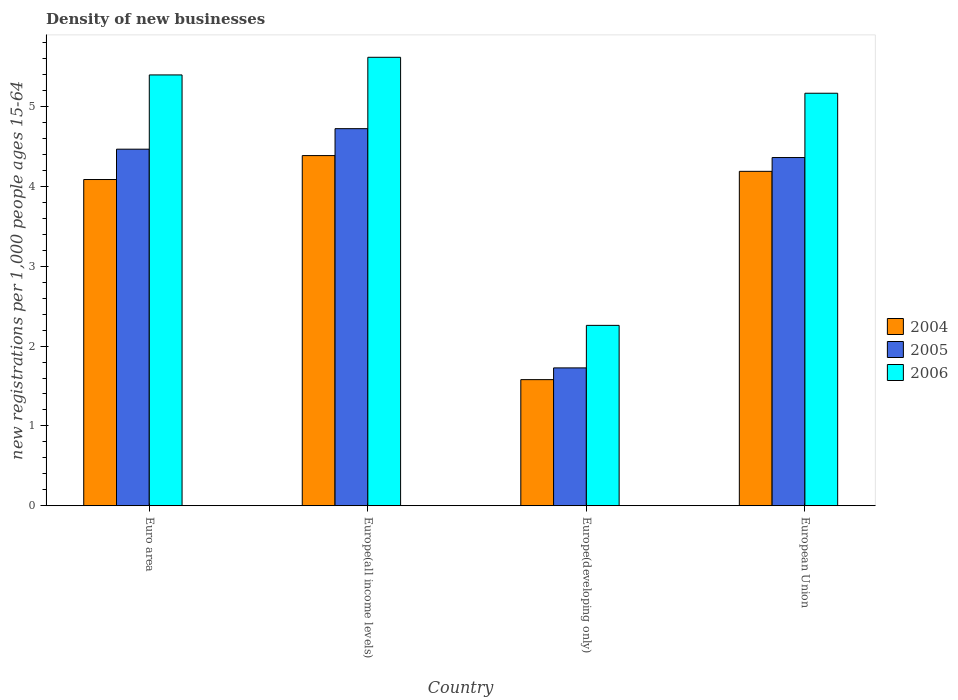How many groups of bars are there?
Your answer should be compact. 4. Are the number of bars per tick equal to the number of legend labels?
Give a very brief answer. Yes. Are the number of bars on each tick of the X-axis equal?
Offer a very short reply. Yes. How many bars are there on the 3rd tick from the right?
Offer a terse response. 3. What is the label of the 3rd group of bars from the left?
Provide a succinct answer. Europe(developing only). What is the number of new registrations in 2006 in European Union?
Provide a succinct answer. 5.17. Across all countries, what is the maximum number of new registrations in 2004?
Offer a terse response. 4.39. Across all countries, what is the minimum number of new registrations in 2004?
Your answer should be very brief. 1.58. In which country was the number of new registrations in 2004 maximum?
Your answer should be compact. Europe(all income levels). In which country was the number of new registrations in 2005 minimum?
Your response must be concise. Europe(developing only). What is the total number of new registrations in 2004 in the graph?
Provide a short and direct response. 14.24. What is the difference between the number of new registrations in 2006 in Europe(all income levels) and that in European Union?
Offer a terse response. 0.45. What is the difference between the number of new registrations in 2004 in Europe(all income levels) and the number of new registrations in 2005 in European Union?
Your response must be concise. 0.02. What is the average number of new registrations in 2006 per country?
Keep it short and to the point. 4.61. What is the difference between the number of new registrations of/in 2005 and number of new registrations of/in 2004 in Europe(all income levels)?
Your answer should be very brief. 0.34. In how many countries, is the number of new registrations in 2004 greater than 1.8?
Make the answer very short. 3. What is the ratio of the number of new registrations in 2004 in Euro area to that in Europe(all income levels)?
Your answer should be very brief. 0.93. What is the difference between the highest and the second highest number of new registrations in 2004?
Your answer should be very brief. 0.2. What is the difference between the highest and the lowest number of new registrations in 2004?
Keep it short and to the point. 2.81. In how many countries, is the number of new registrations in 2006 greater than the average number of new registrations in 2006 taken over all countries?
Give a very brief answer. 3. Is the sum of the number of new registrations in 2006 in Euro area and European Union greater than the maximum number of new registrations in 2004 across all countries?
Keep it short and to the point. Yes. What does the 3rd bar from the left in Europe(all income levels) represents?
Your response must be concise. 2006. What does the 2nd bar from the right in Europe(developing only) represents?
Provide a short and direct response. 2005. Is it the case that in every country, the sum of the number of new registrations in 2006 and number of new registrations in 2005 is greater than the number of new registrations in 2004?
Offer a very short reply. Yes. How many bars are there?
Provide a short and direct response. 12. Are all the bars in the graph horizontal?
Provide a short and direct response. No. What is the difference between two consecutive major ticks on the Y-axis?
Give a very brief answer. 1. Does the graph contain any zero values?
Make the answer very short. No. How many legend labels are there?
Keep it short and to the point. 3. What is the title of the graph?
Keep it short and to the point. Density of new businesses. Does "1999" appear as one of the legend labels in the graph?
Your answer should be compact. No. What is the label or title of the Y-axis?
Your response must be concise. New registrations per 1,0 people ages 15-64. What is the new registrations per 1,000 people ages 15-64 in 2004 in Euro area?
Your answer should be very brief. 4.09. What is the new registrations per 1,000 people ages 15-64 of 2005 in Euro area?
Your answer should be very brief. 4.47. What is the new registrations per 1,000 people ages 15-64 in 2006 in Euro area?
Make the answer very short. 5.4. What is the new registrations per 1,000 people ages 15-64 in 2004 in Europe(all income levels)?
Your answer should be compact. 4.39. What is the new registrations per 1,000 people ages 15-64 of 2005 in Europe(all income levels)?
Offer a terse response. 4.72. What is the new registrations per 1,000 people ages 15-64 of 2006 in Europe(all income levels)?
Your response must be concise. 5.62. What is the new registrations per 1,000 people ages 15-64 of 2004 in Europe(developing only)?
Ensure brevity in your answer.  1.58. What is the new registrations per 1,000 people ages 15-64 of 2005 in Europe(developing only)?
Offer a terse response. 1.73. What is the new registrations per 1,000 people ages 15-64 of 2006 in Europe(developing only)?
Provide a short and direct response. 2.26. What is the new registrations per 1,000 people ages 15-64 of 2004 in European Union?
Ensure brevity in your answer.  4.19. What is the new registrations per 1,000 people ages 15-64 in 2005 in European Union?
Offer a terse response. 4.36. What is the new registrations per 1,000 people ages 15-64 of 2006 in European Union?
Your response must be concise. 5.17. Across all countries, what is the maximum new registrations per 1,000 people ages 15-64 in 2004?
Give a very brief answer. 4.39. Across all countries, what is the maximum new registrations per 1,000 people ages 15-64 in 2005?
Ensure brevity in your answer.  4.72. Across all countries, what is the maximum new registrations per 1,000 people ages 15-64 of 2006?
Your response must be concise. 5.62. Across all countries, what is the minimum new registrations per 1,000 people ages 15-64 of 2004?
Offer a very short reply. 1.58. Across all countries, what is the minimum new registrations per 1,000 people ages 15-64 of 2005?
Provide a succinct answer. 1.73. Across all countries, what is the minimum new registrations per 1,000 people ages 15-64 in 2006?
Offer a very short reply. 2.26. What is the total new registrations per 1,000 people ages 15-64 of 2004 in the graph?
Offer a very short reply. 14.24. What is the total new registrations per 1,000 people ages 15-64 in 2005 in the graph?
Provide a short and direct response. 15.28. What is the total new registrations per 1,000 people ages 15-64 in 2006 in the graph?
Give a very brief answer. 18.44. What is the difference between the new registrations per 1,000 people ages 15-64 of 2004 in Euro area and that in Europe(all income levels)?
Ensure brevity in your answer.  -0.3. What is the difference between the new registrations per 1,000 people ages 15-64 in 2005 in Euro area and that in Europe(all income levels)?
Your response must be concise. -0.26. What is the difference between the new registrations per 1,000 people ages 15-64 of 2006 in Euro area and that in Europe(all income levels)?
Your answer should be compact. -0.22. What is the difference between the new registrations per 1,000 people ages 15-64 of 2004 in Euro area and that in Europe(developing only)?
Ensure brevity in your answer.  2.51. What is the difference between the new registrations per 1,000 people ages 15-64 in 2005 in Euro area and that in Europe(developing only)?
Keep it short and to the point. 2.74. What is the difference between the new registrations per 1,000 people ages 15-64 of 2006 in Euro area and that in Europe(developing only)?
Your response must be concise. 3.14. What is the difference between the new registrations per 1,000 people ages 15-64 of 2004 in Euro area and that in European Union?
Offer a terse response. -0.1. What is the difference between the new registrations per 1,000 people ages 15-64 in 2005 in Euro area and that in European Union?
Your response must be concise. 0.1. What is the difference between the new registrations per 1,000 people ages 15-64 in 2006 in Euro area and that in European Union?
Ensure brevity in your answer.  0.23. What is the difference between the new registrations per 1,000 people ages 15-64 of 2004 in Europe(all income levels) and that in Europe(developing only)?
Your answer should be very brief. 2.81. What is the difference between the new registrations per 1,000 people ages 15-64 in 2005 in Europe(all income levels) and that in Europe(developing only)?
Offer a very short reply. 3. What is the difference between the new registrations per 1,000 people ages 15-64 in 2006 in Europe(all income levels) and that in Europe(developing only)?
Offer a terse response. 3.36. What is the difference between the new registrations per 1,000 people ages 15-64 in 2004 in Europe(all income levels) and that in European Union?
Offer a terse response. 0.2. What is the difference between the new registrations per 1,000 people ages 15-64 in 2005 in Europe(all income levels) and that in European Union?
Give a very brief answer. 0.36. What is the difference between the new registrations per 1,000 people ages 15-64 in 2006 in Europe(all income levels) and that in European Union?
Provide a short and direct response. 0.45. What is the difference between the new registrations per 1,000 people ages 15-64 of 2004 in Europe(developing only) and that in European Union?
Your response must be concise. -2.61. What is the difference between the new registrations per 1,000 people ages 15-64 in 2005 in Europe(developing only) and that in European Union?
Provide a short and direct response. -2.64. What is the difference between the new registrations per 1,000 people ages 15-64 of 2006 in Europe(developing only) and that in European Union?
Give a very brief answer. -2.91. What is the difference between the new registrations per 1,000 people ages 15-64 of 2004 in Euro area and the new registrations per 1,000 people ages 15-64 of 2005 in Europe(all income levels)?
Give a very brief answer. -0.64. What is the difference between the new registrations per 1,000 people ages 15-64 in 2004 in Euro area and the new registrations per 1,000 people ages 15-64 in 2006 in Europe(all income levels)?
Offer a terse response. -1.53. What is the difference between the new registrations per 1,000 people ages 15-64 of 2005 in Euro area and the new registrations per 1,000 people ages 15-64 of 2006 in Europe(all income levels)?
Your response must be concise. -1.15. What is the difference between the new registrations per 1,000 people ages 15-64 in 2004 in Euro area and the new registrations per 1,000 people ages 15-64 in 2005 in Europe(developing only)?
Your answer should be very brief. 2.36. What is the difference between the new registrations per 1,000 people ages 15-64 of 2004 in Euro area and the new registrations per 1,000 people ages 15-64 of 2006 in Europe(developing only)?
Provide a short and direct response. 1.83. What is the difference between the new registrations per 1,000 people ages 15-64 in 2005 in Euro area and the new registrations per 1,000 people ages 15-64 in 2006 in Europe(developing only)?
Keep it short and to the point. 2.21. What is the difference between the new registrations per 1,000 people ages 15-64 in 2004 in Euro area and the new registrations per 1,000 people ages 15-64 in 2005 in European Union?
Keep it short and to the point. -0.28. What is the difference between the new registrations per 1,000 people ages 15-64 in 2004 in Euro area and the new registrations per 1,000 people ages 15-64 in 2006 in European Union?
Your response must be concise. -1.08. What is the difference between the new registrations per 1,000 people ages 15-64 in 2005 in Euro area and the new registrations per 1,000 people ages 15-64 in 2006 in European Union?
Give a very brief answer. -0.7. What is the difference between the new registrations per 1,000 people ages 15-64 of 2004 in Europe(all income levels) and the new registrations per 1,000 people ages 15-64 of 2005 in Europe(developing only)?
Offer a very short reply. 2.66. What is the difference between the new registrations per 1,000 people ages 15-64 in 2004 in Europe(all income levels) and the new registrations per 1,000 people ages 15-64 in 2006 in Europe(developing only)?
Offer a terse response. 2.13. What is the difference between the new registrations per 1,000 people ages 15-64 in 2005 in Europe(all income levels) and the new registrations per 1,000 people ages 15-64 in 2006 in Europe(developing only)?
Give a very brief answer. 2.46. What is the difference between the new registrations per 1,000 people ages 15-64 of 2004 in Europe(all income levels) and the new registrations per 1,000 people ages 15-64 of 2005 in European Union?
Keep it short and to the point. 0.02. What is the difference between the new registrations per 1,000 people ages 15-64 of 2004 in Europe(all income levels) and the new registrations per 1,000 people ages 15-64 of 2006 in European Union?
Ensure brevity in your answer.  -0.78. What is the difference between the new registrations per 1,000 people ages 15-64 of 2005 in Europe(all income levels) and the new registrations per 1,000 people ages 15-64 of 2006 in European Union?
Keep it short and to the point. -0.44. What is the difference between the new registrations per 1,000 people ages 15-64 of 2004 in Europe(developing only) and the new registrations per 1,000 people ages 15-64 of 2005 in European Union?
Make the answer very short. -2.78. What is the difference between the new registrations per 1,000 people ages 15-64 of 2004 in Europe(developing only) and the new registrations per 1,000 people ages 15-64 of 2006 in European Union?
Give a very brief answer. -3.59. What is the difference between the new registrations per 1,000 people ages 15-64 in 2005 in Europe(developing only) and the new registrations per 1,000 people ages 15-64 in 2006 in European Union?
Your answer should be compact. -3.44. What is the average new registrations per 1,000 people ages 15-64 in 2004 per country?
Keep it short and to the point. 3.56. What is the average new registrations per 1,000 people ages 15-64 in 2005 per country?
Your response must be concise. 3.82. What is the average new registrations per 1,000 people ages 15-64 of 2006 per country?
Provide a succinct answer. 4.61. What is the difference between the new registrations per 1,000 people ages 15-64 of 2004 and new registrations per 1,000 people ages 15-64 of 2005 in Euro area?
Ensure brevity in your answer.  -0.38. What is the difference between the new registrations per 1,000 people ages 15-64 in 2004 and new registrations per 1,000 people ages 15-64 in 2006 in Euro area?
Offer a very short reply. -1.31. What is the difference between the new registrations per 1,000 people ages 15-64 of 2005 and new registrations per 1,000 people ages 15-64 of 2006 in Euro area?
Offer a very short reply. -0.93. What is the difference between the new registrations per 1,000 people ages 15-64 of 2004 and new registrations per 1,000 people ages 15-64 of 2005 in Europe(all income levels)?
Offer a very short reply. -0.34. What is the difference between the new registrations per 1,000 people ages 15-64 in 2004 and new registrations per 1,000 people ages 15-64 in 2006 in Europe(all income levels)?
Your response must be concise. -1.23. What is the difference between the new registrations per 1,000 people ages 15-64 of 2005 and new registrations per 1,000 people ages 15-64 of 2006 in Europe(all income levels)?
Give a very brief answer. -0.89. What is the difference between the new registrations per 1,000 people ages 15-64 in 2004 and new registrations per 1,000 people ages 15-64 in 2005 in Europe(developing only)?
Provide a succinct answer. -0.15. What is the difference between the new registrations per 1,000 people ages 15-64 in 2004 and new registrations per 1,000 people ages 15-64 in 2006 in Europe(developing only)?
Make the answer very short. -0.68. What is the difference between the new registrations per 1,000 people ages 15-64 in 2005 and new registrations per 1,000 people ages 15-64 in 2006 in Europe(developing only)?
Offer a very short reply. -0.53. What is the difference between the new registrations per 1,000 people ages 15-64 in 2004 and new registrations per 1,000 people ages 15-64 in 2005 in European Union?
Your response must be concise. -0.17. What is the difference between the new registrations per 1,000 people ages 15-64 of 2004 and new registrations per 1,000 people ages 15-64 of 2006 in European Union?
Make the answer very short. -0.98. What is the difference between the new registrations per 1,000 people ages 15-64 of 2005 and new registrations per 1,000 people ages 15-64 of 2006 in European Union?
Give a very brief answer. -0.81. What is the ratio of the new registrations per 1,000 people ages 15-64 in 2004 in Euro area to that in Europe(all income levels)?
Keep it short and to the point. 0.93. What is the ratio of the new registrations per 1,000 people ages 15-64 in 2005 in Euro area to that in Europe(all income levels)?
Offer a terse response. 0.95. What is the ratio of the new registrations per 1,000 people ages 15-64 in 2006 in Euro area to that in Europe(all income levels)?
Provide a succinct answer. 0.96. What is the ratio of the new registrations per 1,000 people ages 15-64 in 2004 in Euro area to that in Europe(developing only)?
Offer a very short reply. 2.59. What is the ratio of the new registrations per 1,000 people ages 15-64 in 2005 in Euro area to that in Europe(developing only)?
Your answer should be very brief. 2.59. What is the ratio of the new registrations per 1,000 people ages 15-64 in 2006 in Euro area to that in Europe(developing only)?
Offer a very short reply. 2.39. What is the ratio of the new registrations per 1,000 people ages 15-64 in 2004 in Euro area to that in European Union?
Your answer should be compact. 0.98. What is the ratio of the new registrations per 1,000 people ages 15-64 of 2005 in Euro area to that in European Union?
Your response must be concise. 1.02. What is the ratio of the new registrations per 1,000 people ages 15-64 of 2006 in Euro area to that in European Union?
Your answer should be compact. 1.04. What is the ratio of the new registrations per 1,000 people ages 15-64 in 2004 in Europe(all income levels) to that in Europe(developing only)?
Offer a terse response. 2.78. What is the ratio of the new registrations per 1,000 people ages 15-64 in 2005 in Europe(all income levels) to that in Europe(developing only)?
Your answer should be compact. 2.74. What is the ratio of the new registrations per 1,000 people ages 15-64 in 2006 in Europe(all income levels) to that in Europe(developing only)?
Provide a succinct answer. 2.49. What is the ratio of the new registrations per 1,000 people ages 15-64 in 2004 in Europe(all income levels) to that in European Union?
Keep it short and to the point. 1.05. What is the ratio of the new registrations per 1,000 people ages 15-64 of 2005 in Europe(all income levels) to that in European Union?
Offer a terse response. 1.08. What is the ratio of the new registrations per 1,000 people ages 15-64 of 2006 in Europe(all income levels) to that in European Union?
Give a very brief answer. 1.09. What is the ratio of the new registrations per 1,000 people ages 15-64 of 2004 in Europe(developing only) to that in European Union?
Keep it short and to the point. 0.38. What is the ratio of the new registrations per 1,000 people ages 15-64 in 2005 in Europe(developing only) to that in European Union?
Make the answer very short. 0.4. What is the ratio of the new registrations per 1,000 people ages 15-64 of 2006 in Europe(developing only) to that in European Union?
Your answer should be very brief. 0.44. What is the difference between the highest and the second highest new registrations per 1,000 people ages 15-64 of 2004?
Ensure brevity in your answer.  0.2. What is the difference between the highest and the second highest new registrations per 1,000 people ages 15-64 of 2005?
Your answer should be very brief. 0.26. What is the difference between the highest and the second highest new registrations per 1,000 people ages 15-64 of 2006?
Offer a terse response. 0.22. What is the difference between the highest and the lowest new registrations per 1,000 people ages 15-64 of 2004?
Make the answer very short. 2.81. What is the difference between the highest and the lowest new registrations per 1,000 people ages 15-64 in 2005?
Make the answer very short. 3. What is the difference between the highest and the lowest new registrations per 1,000 people ages 15-64 of 2006?
Your answer should be very brief. 3.36. 